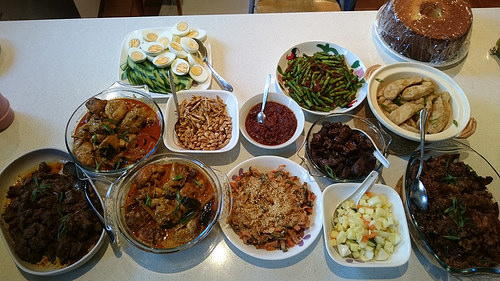<image>
Is the bowl on the spoon? No. The bowl is not positioned on the spoon. They may be near each other, but the bowl is not supported by or resting on top of the spoon. Where is the spoon in relation to the bowl? Is it in the bowl? No. The spoon is not contained within the bowl. These objects have a different spatial relationship. 